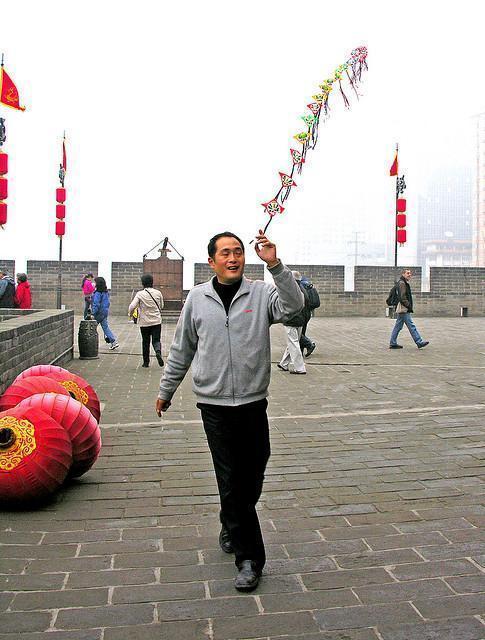The man closest to the right has what kind of pants on?
Pick the right solution, then justify: 'Answer: answer
Rationale: rationale.'
Options: Jeans, khakis, shorts, tights. Answer: jeans.
Rationale: The man's pants are blue. blue denim is the most common material from which jeans are made. 